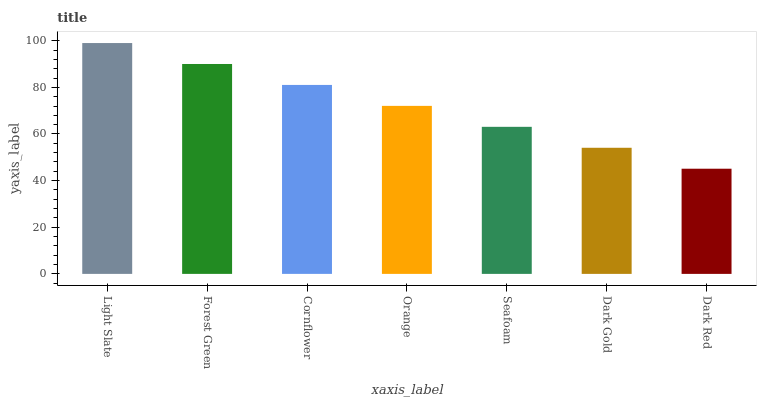Is Dark Red the minimum?
Answer yes or no. Yes. Is Light Slate the maximum?
Answer yes or no. Yes. Is Forest Green the minimum?
Answer yes or no. No. Is Forest Green the maximum?
Answer yes or no. No. Is Light Slate greater than Forest Green?
Answer yes or no. Yes. Is Forest Green less than Light Slate?
Answer yes or no. Yes. Is Forest Green greater than Light Slate?
Answer yes or no. No. Is Light Slate less than Forest Green?
Answer yes or no. No. Is Orange the high median?
Answer yes or no. Yes. Is Orange the low median?
Answer yes or no. Yes. Is Dark Red the high median?
Answer yes or no. No. Is Light Slate the low median?
Answer yes or no. No. 